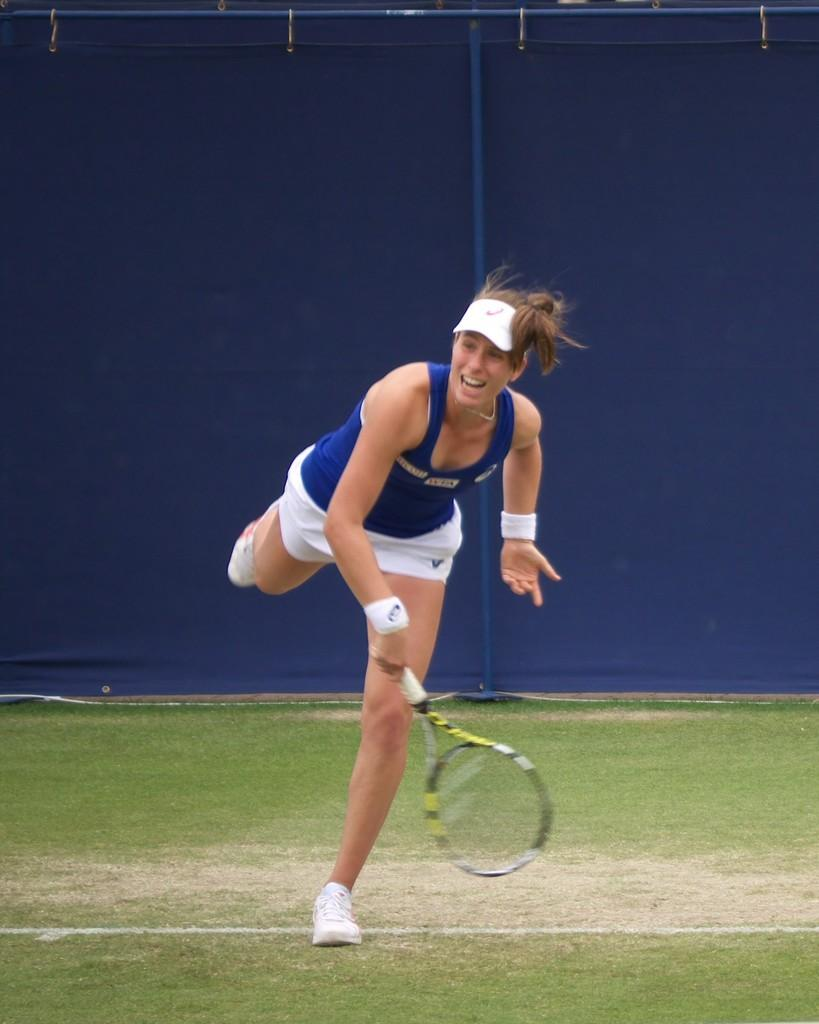Who is present in the image? There is a woman in the image. What is the woman doing in the image? The woman is in motion, and she is holding a racket. What type of surface is visible in the image? There is grass visible in the image. What can be seen in the background of the image? There are rods in the background of the image, and the background is blue. How far can the woman jump in the image? The image does not show the woman jumping, so it is not possible to determine how far she can jump. What type of iron is present in the image? There is no iron present in the image. 